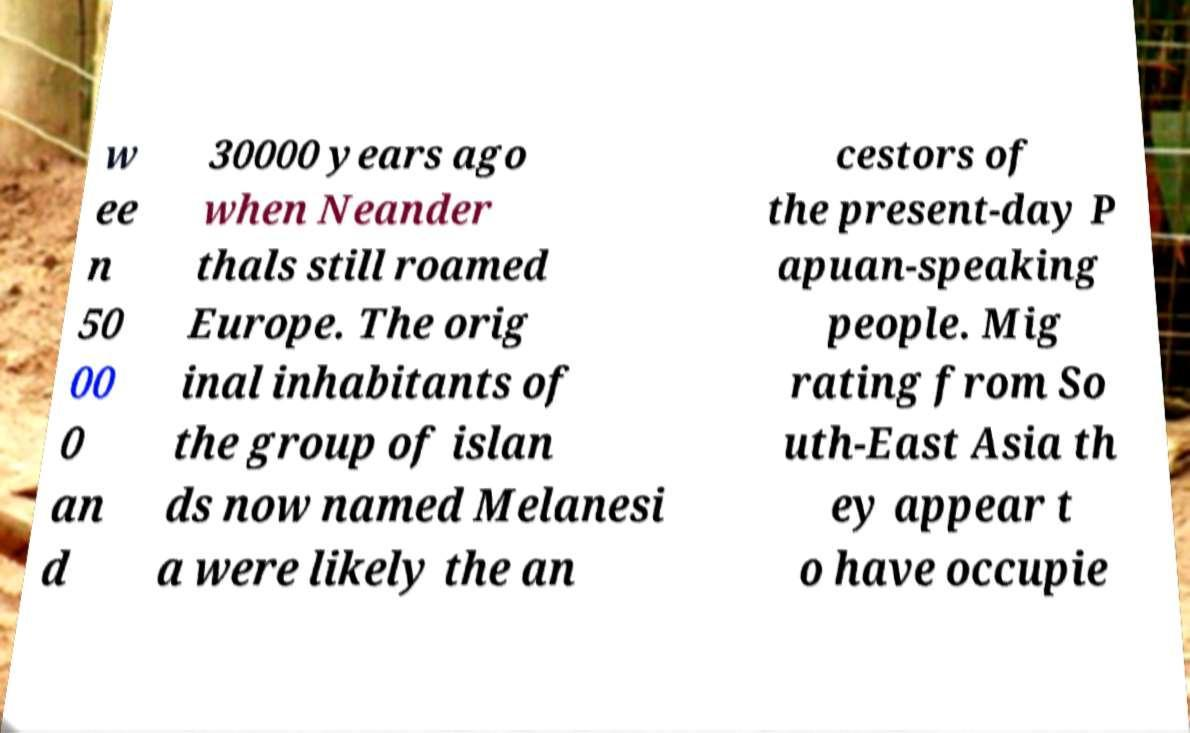Can you accurately transcribe the text from the provided image for me? w ee n 50 00 0 an d 30000 years ago when Neander thals still roamed Europe. The orig inal inhabitants of the group of islan ds now named Melanesi a were likely the an cestors of the present-day P apuan-speaking people. Mig rating from So uth-East Asia th ey appear t o have occupie 